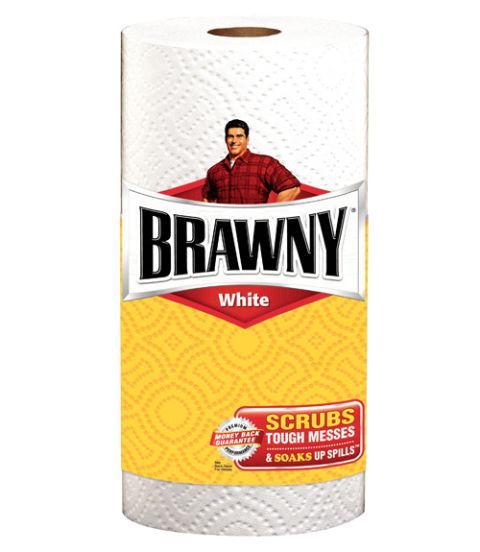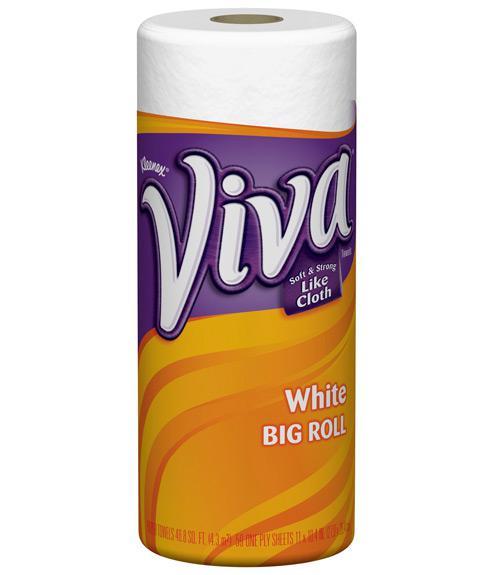The first image is the image on the left, the second image is the image on the right. For the images shown, is this caption "The paper towel packaging on the left depicts a man in a red flannel shirt, but the paper towel packaging on the right does not." true? Answer yes or no. Yes. The first image is the image on the left, the second image is the image on the right. Evaluate the accuracy of this statement regarding the images: "The left image contains at least six rolls of paper towels.". Is it true? Answer yes or no. No. 